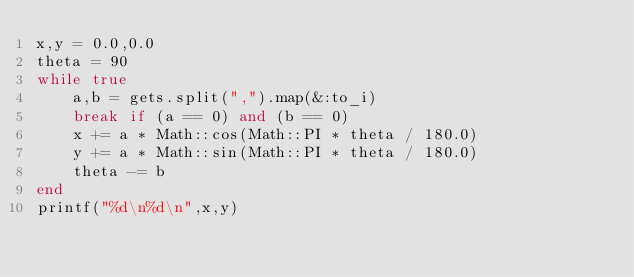<code> <loc_0><loc_0><loc_500><loc_500><_Ruby_>x,y = 0.0,0.0
theta = 90
while true
    a,b = gets.split(",").map(&:to_i)
    break if (a == 0) and (b == 0)
    x += a * Math::cos(Math::PI * theta / 180.0)
    y += a * Math::sin(Math::PI * theta / 180.0)
    theta -= b
end
printf("%d\n%d\n",x,y)</code> 